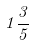Convert formula to latex. <formula><loc_0><loc_0><loc_500><loc_500>1 \frac { 3 } { 5 }</formula> 